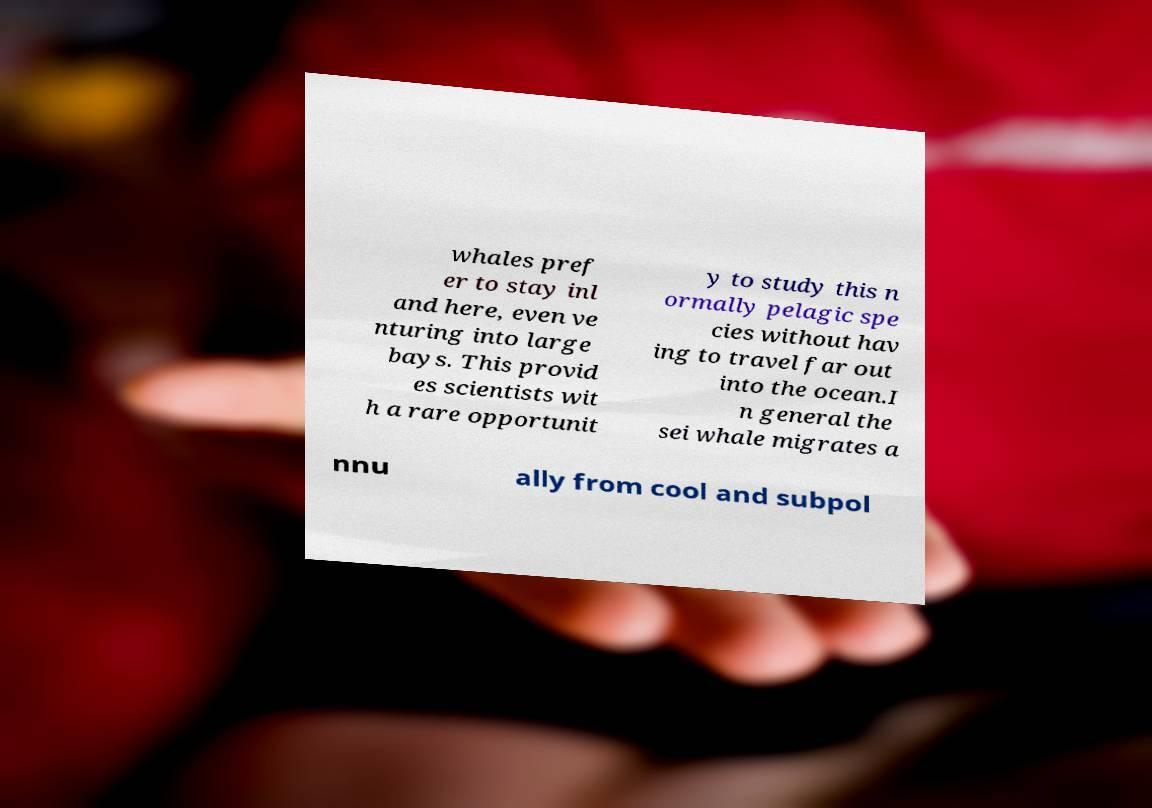For documentation purposes, I need the text within this image transcribed. Could you provide that? whales pref er to stay inl and here, even ve nturing into large bays. This provid es scientists wit h a rare opportunit y to study this n ormally pelagic spe cies without hav ing to travel far out into the ocean.I n general the sei whale migrates a nnu ally from cool and subpol 